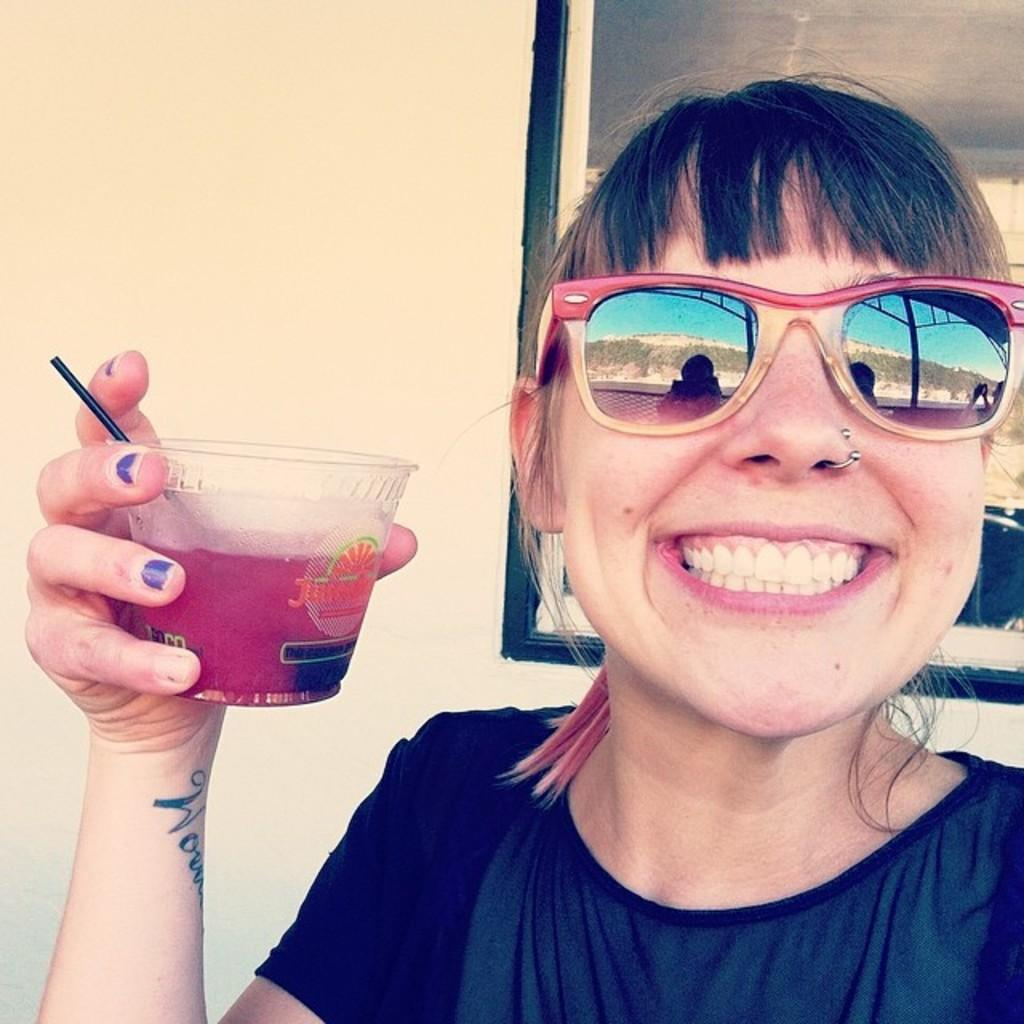Who is the main subject in the image? There is a woman in the image. What is the woman holding in her hand? The woman is holding an object in her hand. Can you describe the woman's clothing? The woman is wearing dark color clothes. What accessory is the woman wearing on her face? The woman is wearing shades. What can be seen in the background of the image? There is a photo attached to the wall in the background of the image. What type of dirt can be seen on the woman's shoes in the image? There is no dirt visible on the woman's shoes in the image, as the facts provided do not mention any dirt or shoes. --- Facts: 1. There is a car in the image. 2. The car is parked on the street. 3. The car has a red color. 4. There are trees on the side of the street. 5. The sky is visible in the image. Absurd Topics: parrot, sand, dance Conversation: What is the main subject in the image? There is a car in the image. Where is the car located? The car is parked on the street. Can you describe the color of the car? The car has a red color. What type of vegetation is present on the side of the street? There are trees on the side of the street. What is visible in the background of the image? The sky is visible in the image. Reasoning: Let's think step by step in order to produce the conversation. We start by identifying the main subject in the image, which is the car. Then, we expand the conversation to include details about the car's location, color, and the surrounding environment, such as the trees and sky. Each question is designed to elicit a specific detail about the image that is known from the provided facts. Absurd Question/Answer: Can you tell me how many parrots are sitting on the car in the image? There are no parrots present in the image; it features a red car parked on the street with trees and the sky visible in the background. 